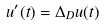Convert formula to latex. <formula><loc_0><loc_0><loc_500><loc_500>u ^ { \prime } ( t ) = \Delta _ { D } u ( t )</formula> 